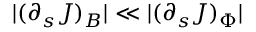Convert formula to latex. <formula><loc_0><loc_0><loc_500><loc_500>| ( \partial _ { s } J ) _ { B } | \ll | ( \partial _ { s } J ) _ { \Phi } |</formula> 